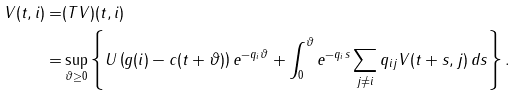<formula> <loc_0><loc_0><loc_500><loc_500>V ( t , i ) = & ( T V ) ( t , i ) \\ = & \sup _ { \vartheta \geq 0 } \left \{ U \left ( g ( i ) - c ( t + \vartheta ) \right ) e ^ { - q _ { i } \vartheta } + \int _ { 0 } ^ { \vartheta } e ^ { - q _ { i } s } \sum _ { j \neq i } q _ { i j } V ( t + s , j ) \, d s \right \} .</formula> 